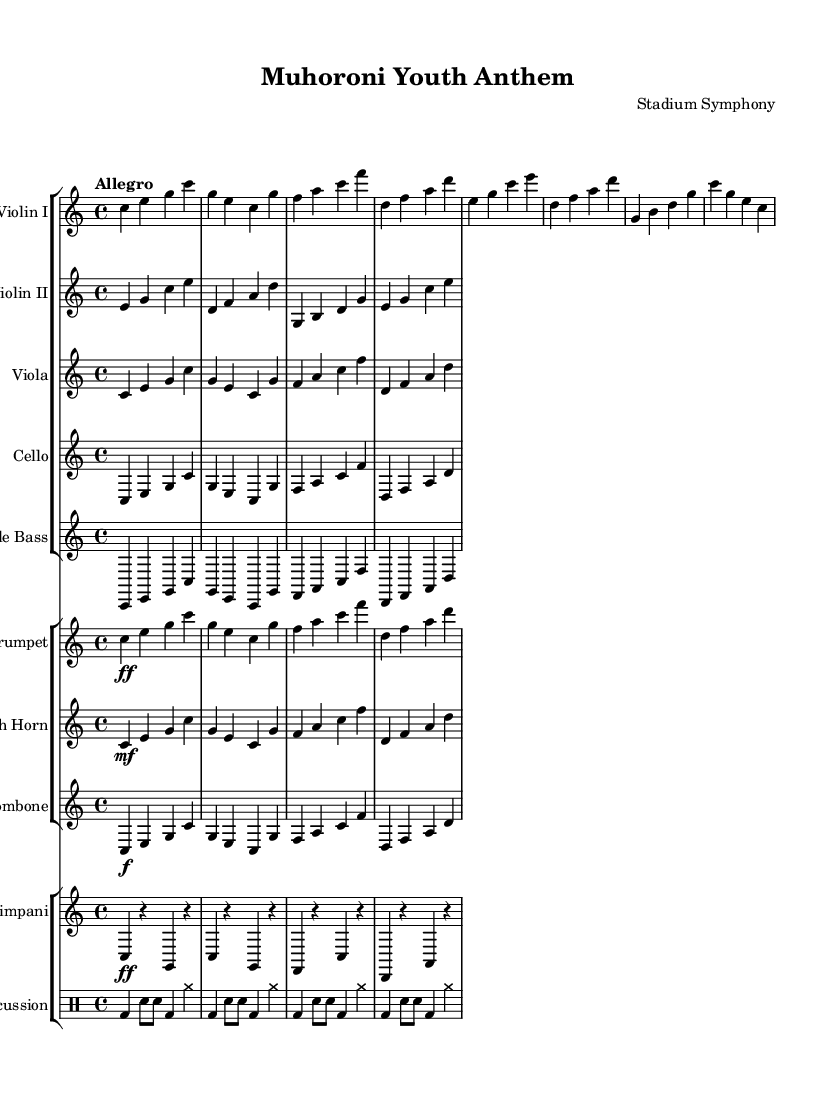What is the key signature of this music? The key signature is C major, which is indicated by the absence of sharps or flats in the sheet music.
Answer: C major What is the time signature of this music? The time signature is found at the beginning of the score, which is 4/4, meaning there are four beats in each measure.
Answer: 4/4 What is the tempo marking of this composition? The tempo marking is 'Allegro', which suggests a fast and lively pace for the piece, typically ranging from 120 to 168 beats per minute.
Answer: Allegro How many instruments are featured in this symphony? The score includes a total of 10 unique instrumental parts including strings, brass, percussion, and drums.
Answer: 10 Which instrument plays the melody initially? In the provided score, it is primarily Violin I that is responsible for carrying the melody in the initial sections.
Answer: Violin I What type of percussion instruments are included? The percussion section features a Timpani and general percussion instruments as indicated by the 'drummode' notation for rhythms and beats.
Answer: Timpani and percussion How does the dynamics change in the trumpet parts? The dynamics in the trumpet parts start at forte, indicated by the 'ff' marking, which denotes a loud intensity in the music.
Answer: forte 